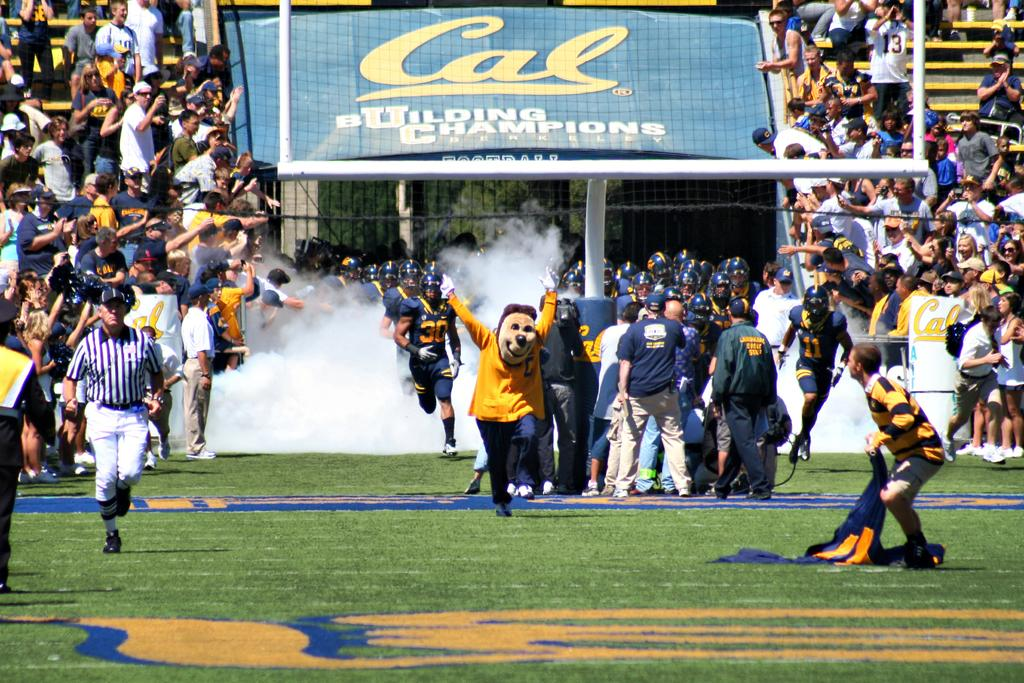<image>
Provide a brief description of the given image. a sign that has the letters cal at the top 